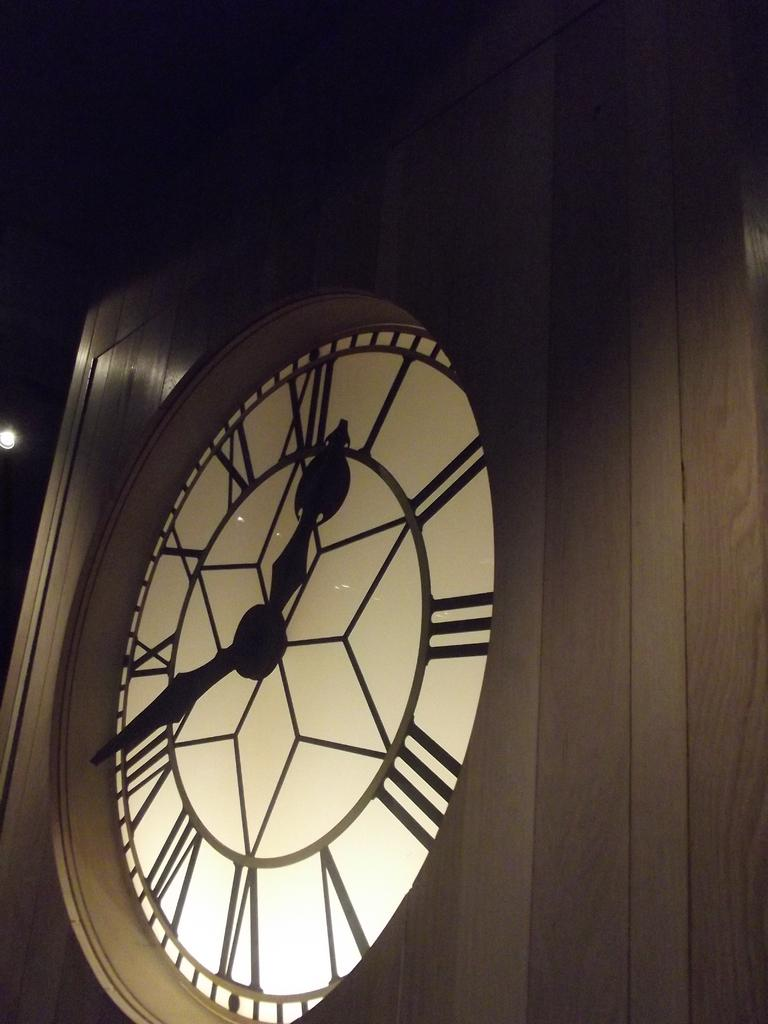What object is the main focus of the image? There is a clock in the image. Where is the clock located? The clock is on a wooden wall. What features does the clock have? The clock has a minute hand and an hour hand. How would you describe the background of the image? The background of the image is dark. What type of manager is depicted in the image? There is no manager present in the image; it features a clock on a wooden wall. How many railway tracks can be seen in the image? There are no railway tracks present in the image; it features a clock on a wooden wall. 